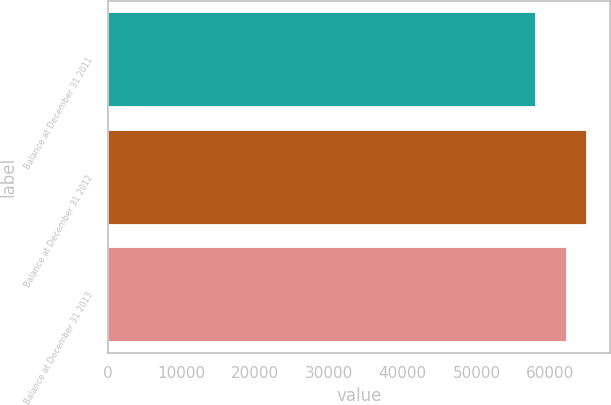Convert chart. <chart><loc_0><loc_0><loc_500><loc_500><bar_chart><fcel>Balance at December 31 2011<fcel>Balance at December 31 2012<fcel>Balance at December 31 2013<nl><fcel>57889<fcel>64837<fcel>62096<nl></chart> 